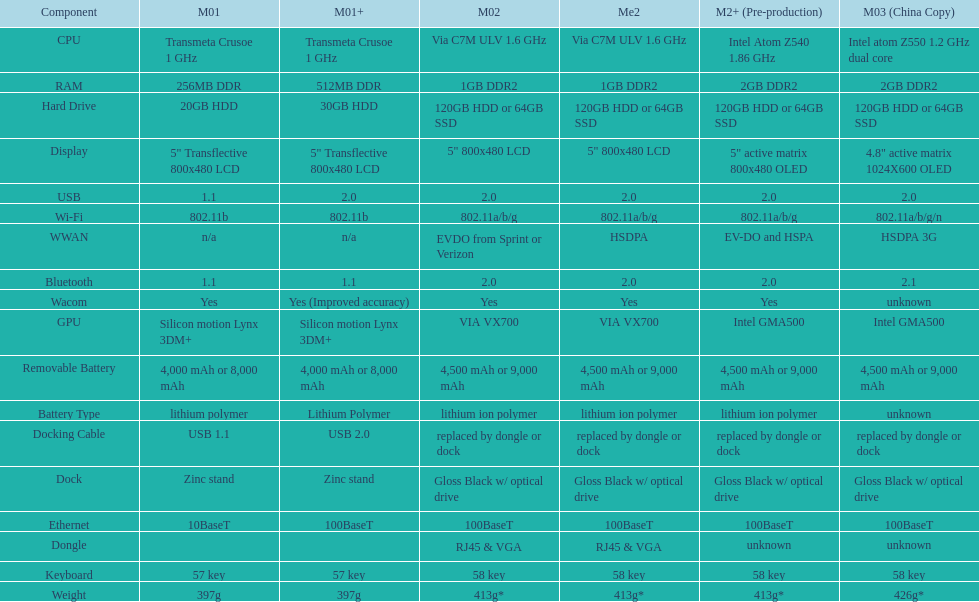What is the total number of components on the chart? 18. 